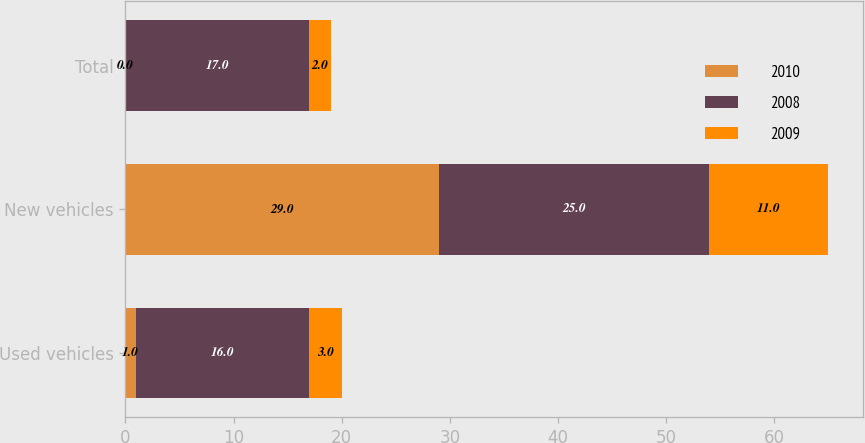Convert chart. <chart><loc_0><loc_0><loc_500><loc_500><stacked_bar_chart><ecel><fcel>Used vehicles<fcel>New vehicles<fcel>Total<nl><fcel>2010<fcel>1<fcel>29<fcel>0<nl><fcel>2008<fcel>16<fcel>25<fcel>17<nl><fcel>2009<fcel>3<fcel>11<fcel>2<nl></chart> 